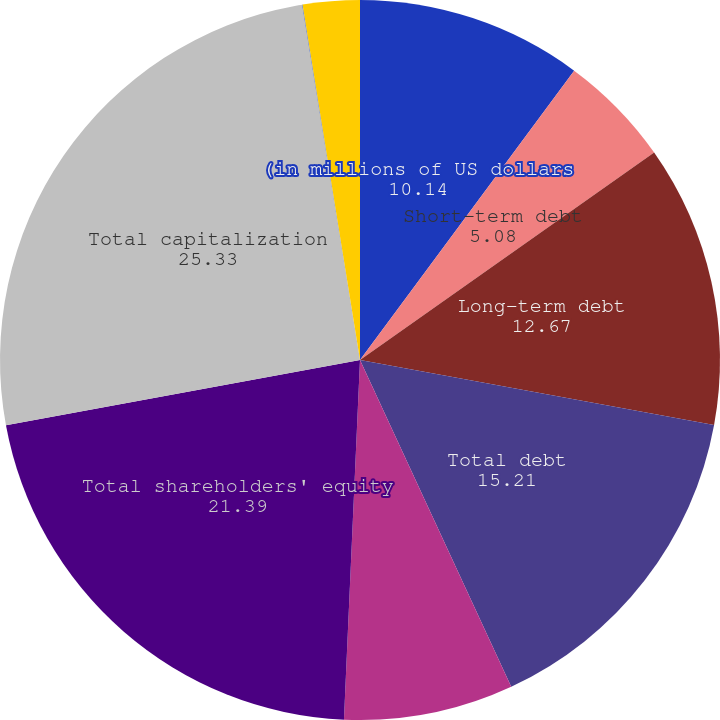<chart> <loc_0><loc_0><loc_500><loc_500><pie_chart><fcel>(in millions of US dollars<fcel>Short-term debt<fcel>Long-term debt<fcel>Total debt<fcel>Trust preferred securities<fcel>Total shareholders' equity<fcel>Total capitalization<fcel>Ratio of debt to total<fcel>Ratio of debt plus trust<nl><fcel>10.14%<fcel>5.08%<fcel>12.67%<fcel>15.21%<fcel>7.61%<fcel>21.39%<fcel>25.33%<fcel>0.02%<fcel>2.55%<nl></chart> 